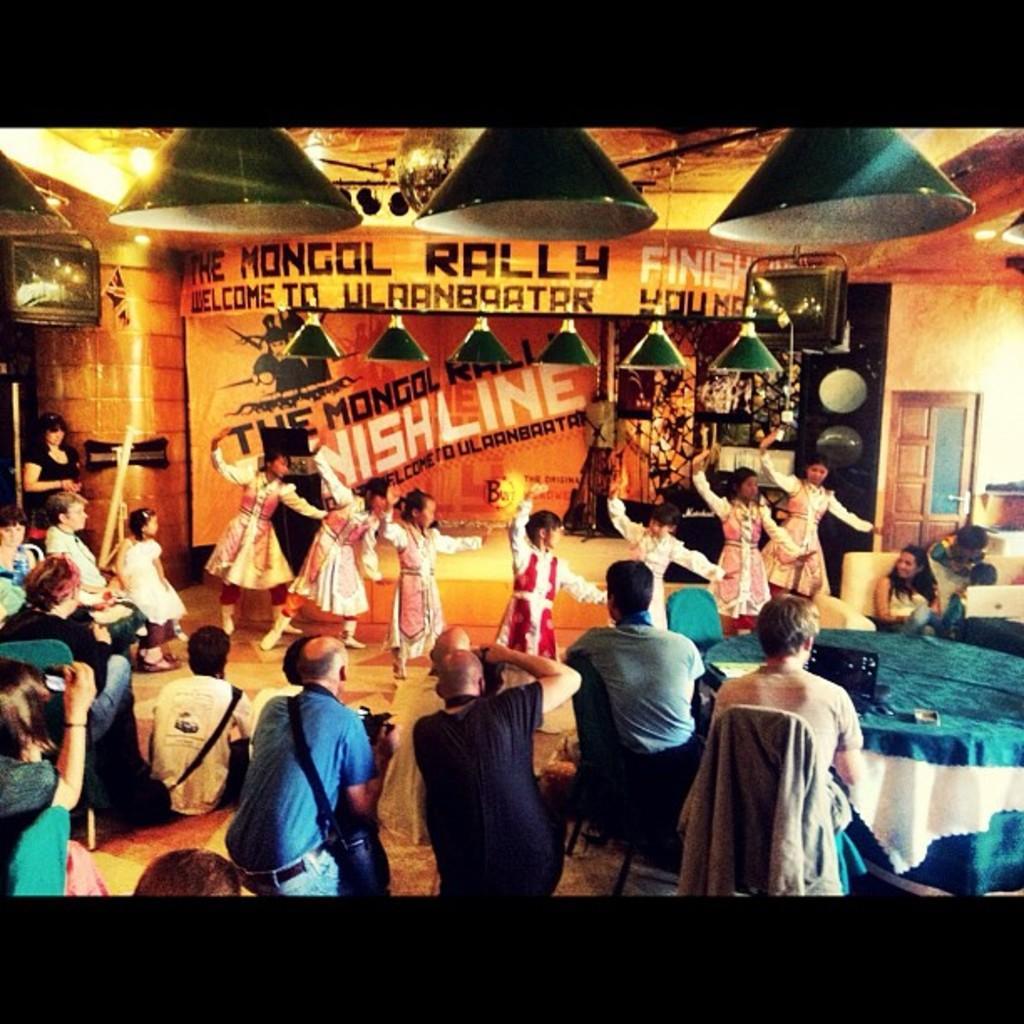Could you give a brief overview of what you see in this image? In this image we can see some group of persons dancing, in the foreground of the image we can see some persons sitting on chairs around tables, we can see some cameraman and in the background of the image there is a wall, sound box and there are some lights. 